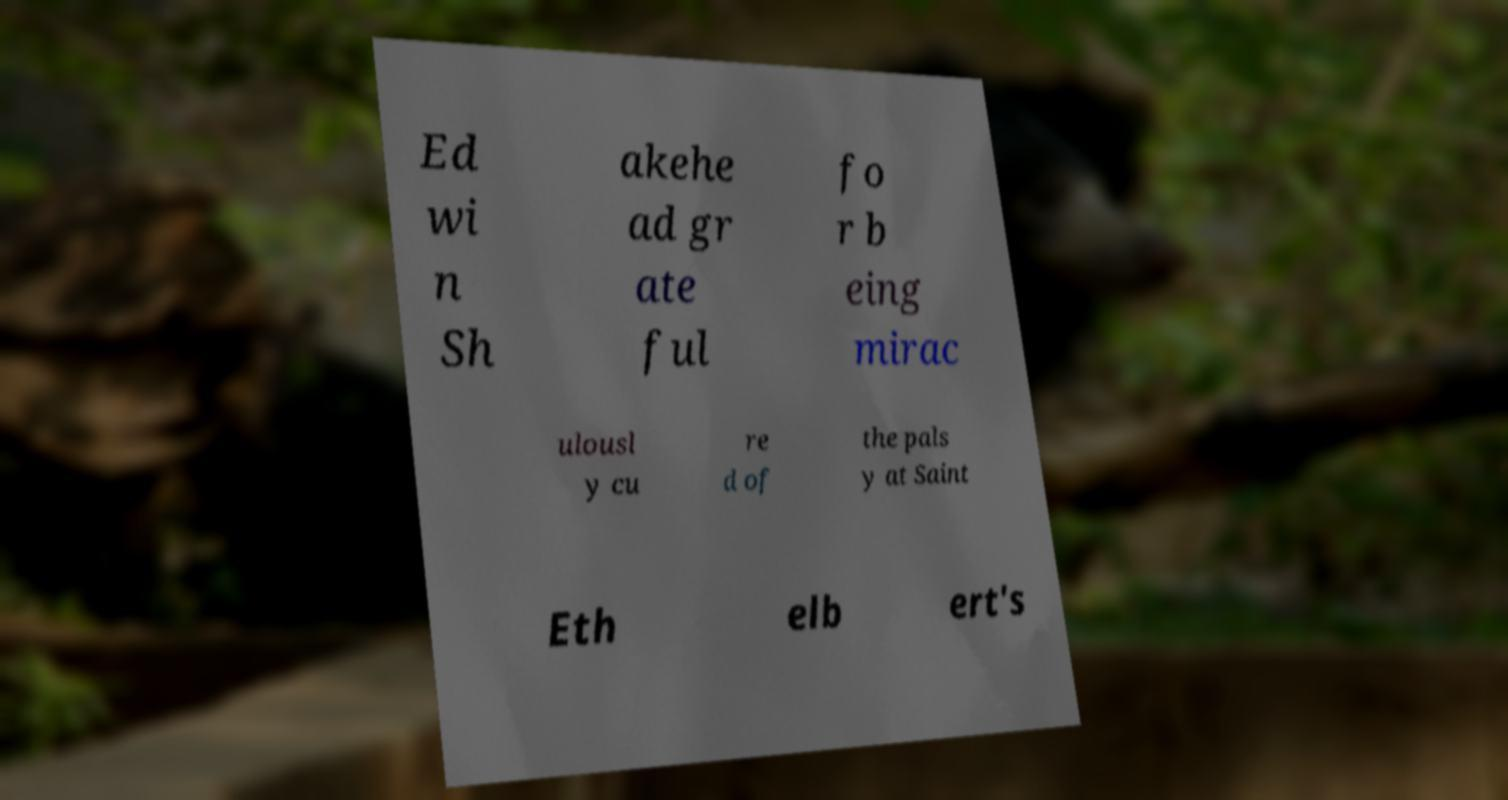For documentation purposes, I need the text within this image transcribed. Could you provide that? Ed wi n Sh akehe ad gr ate ful fo r b eing mirac ulousl y cu re d of the pals y at Saint Eth elb ert's 